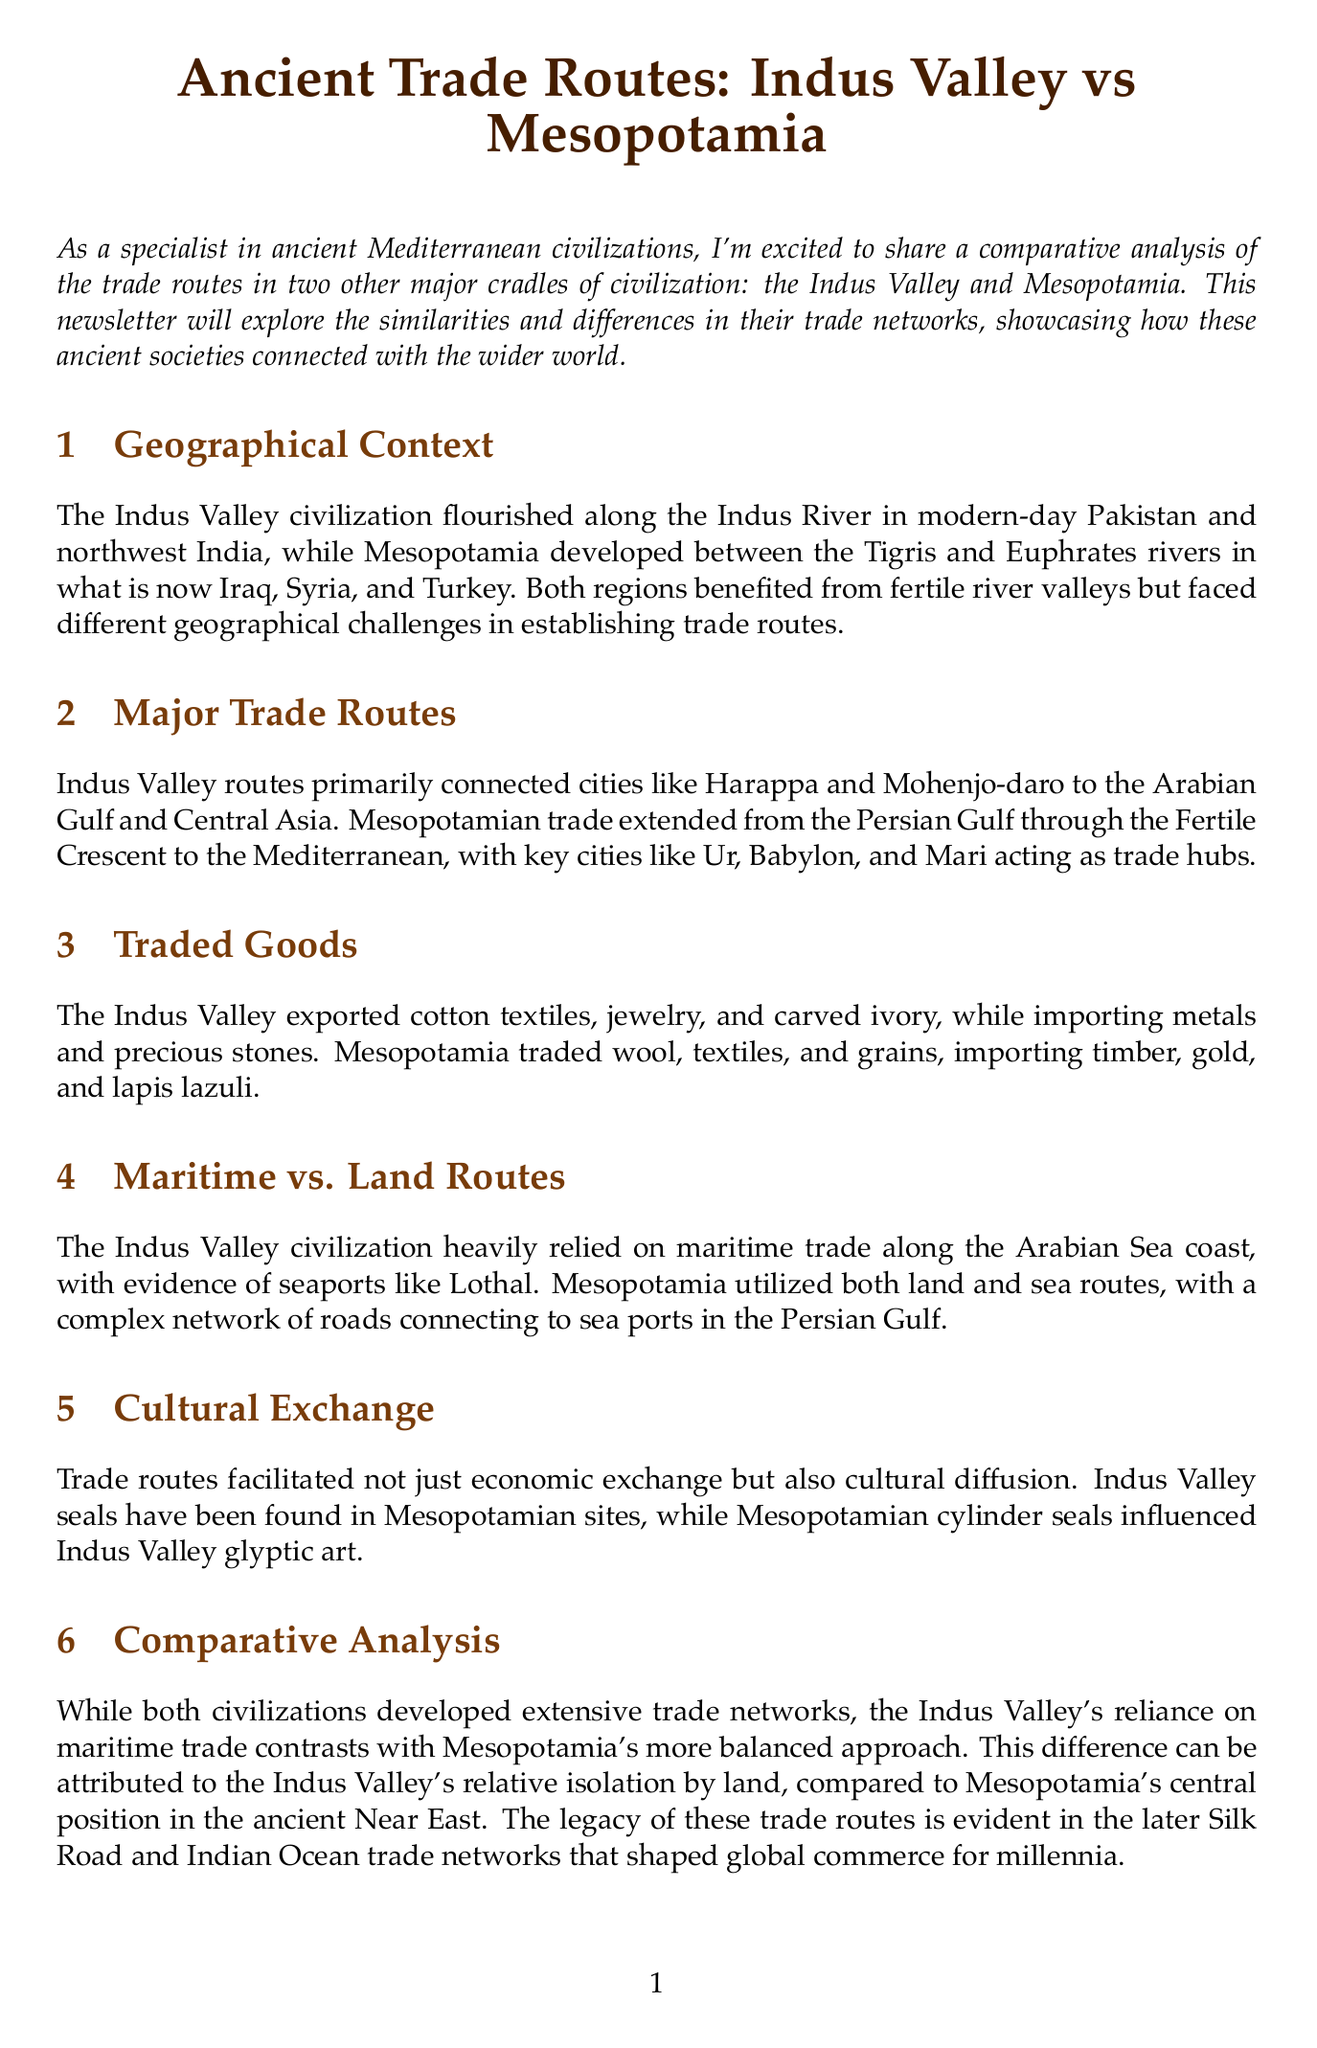What rivers defined the geographical context of Mesopotamia? Mesopotamia developed between the Tigris and Euphrates rivers.
Answer: Tigris and Euphrates Which key city is mentioned as a trade hub in Mesopotamia? Ur is identified as one of the key trade hubs in Mesopotamia.
Answer: Ur What was a major export of the Indus Valley civilization? The document states that cotton textiles were exported from the Indus Valley.
Answer: Cotton textiles What type of trade routes did the Indus Valley heavily rely on? The newsletter mentions that the Indus Valley civilization relied on maritime trade.
Answer: Maritime trade How do the trade routes of the Indus Valley and Mesopotamia primarily differ? The Indus Valley's reliance on maritime trade contrasts with Mesopotamia's balanced approach utilizing both.
Answer: Maritime vs. balanced What artifact image is referenced in the Cultural Exchange section? The document mentions an Indus Valley seal discovered in the ancient Mesopotamian city of Ur.
Answer: Indus Valley seal In what year was "The Archaeology of South Asian Civilization" published? The year of publication for the book is specified in the further reading section.
Answer: 2021 Which civilization relied on land routes connecting to sea ports? The document states that Mesopotamia utilized both land and sea routes.
Answer: Mesopotamia 